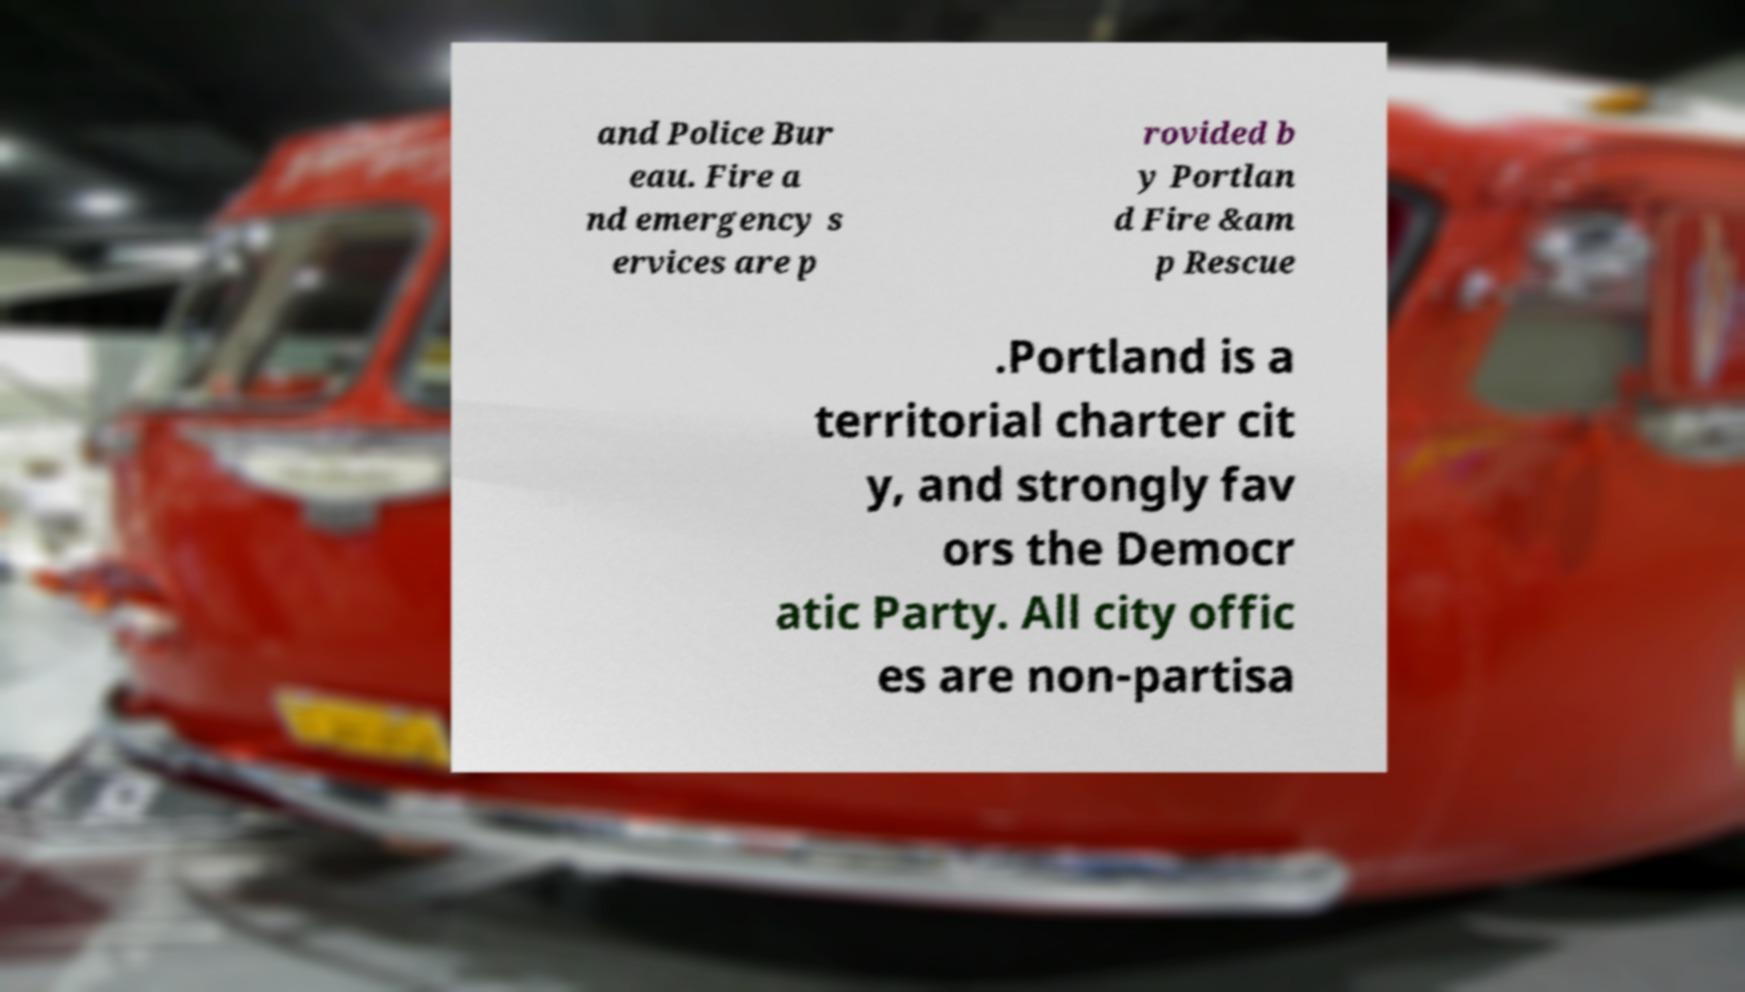Please read and relay the text visible in this image. What does it say? and Police Bur eau. Fire a nd emergency s ervices are p rovided b y Portlan d Fire &am p Rescue .Portland is a territorial charter cit y, and strongly fav ors the Democr atic Party. All city offic es are non-partisa 